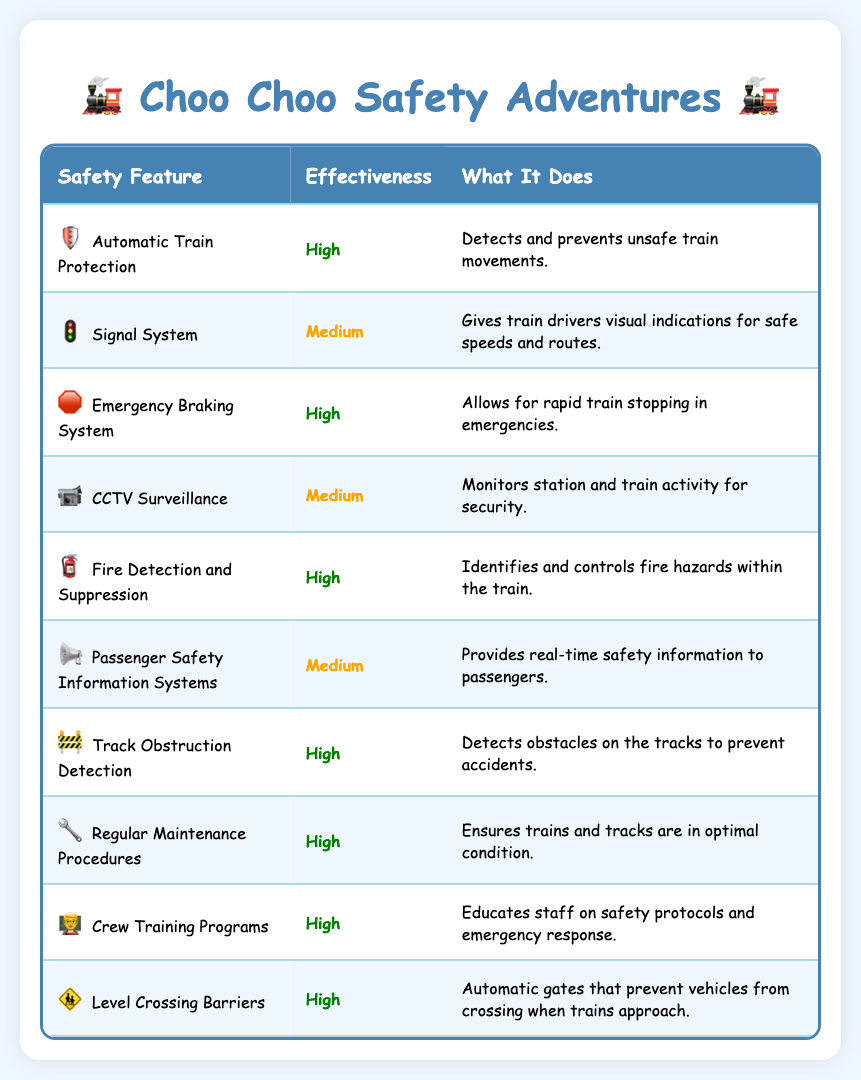What is the effectiveness of the Automatic Train Protection feature? The table shows the effectiveness of various train safety features. Looking at the row for Automatic Train Protection, it indicates that the effectiveness is labeled as "High."
Answer: High Which safety feature has a "Medium" effectiveness? Scanning through the effectiveness column, I identify that both the Signal System, CCTV Surveillance, and Passenger Safety Information Systems are marked as having "Medium" effectiveness. Therefore, any of these three features is a correct answer.
Answer: Signal System, CCTV Surveillance, or Passenger Safety Information Systems How many features have a "High" effectiveness? By counting the rows in the effectiveness column marked as "High," I see they are Automatic Train Protection, Emergency Braking System, Fire Detection and Suppression, Track Obstruction Detection, Regular Maintenance Procedures, Crew Training Programs, and Level Crossing Barriers. This gives a total of 7 features.
Answer: 7 Is the Fire Detection and Suppression feature effective? The table lists Fire Detection and Suppression under the effectiveness column and indicates its effectiveness as "High," confirming that it is indeed effective.
Answer: Yes What feature allows for rapid train stopping in emergencies and what is its effectiveness? Referring to the table, I find the Emergency Braking System, which is specifically mentioned to "Allow for rapid train stopping in emergencies." In the effectiveness column for this feature, it states that it is "High."
Answer: Emergency Braking System, High How many features related to monitoring or information have a "Medium" effectiveness? I look at the features that provide monitoring or information services, which are CCTV Surveillance and Passenger Safety Information Systems. Both marked with "Medium" effectiveness, that makes a total of 2 such features.
Answer: 2 Which features are both "High" in effectiveness and assist in preventing accidents? I identify the features from the table. The two features that assist in preventing accidents and are "High" in effectiveness are the Automatic Train Protection and Track Obstruction Detection. I arrive at this conclusion by scanning for features that help maintain safety and checking their effectiveness.
Answer: Automatic Train Protection and Track Obstruction Detection What is the difference in effectiveness between the Signal System and the Emergency Braking System? The Signal System has a "Medium" effectiveness, while the Emergency Braking System has a "High" effectiveness. Therefore, the difference is between "Medium" and "High," where the latter is more effective.
Answer: High is more effective than Medium Are there any safety features that do not contribute directly to passenger safety? The table defines several features, but most relate directly to passenger safety. The only exception may be Regular Maintenance Procedures, which ensures trains and tracks are optimal rather than directly focusing on the passengers.
Answer: Yes 